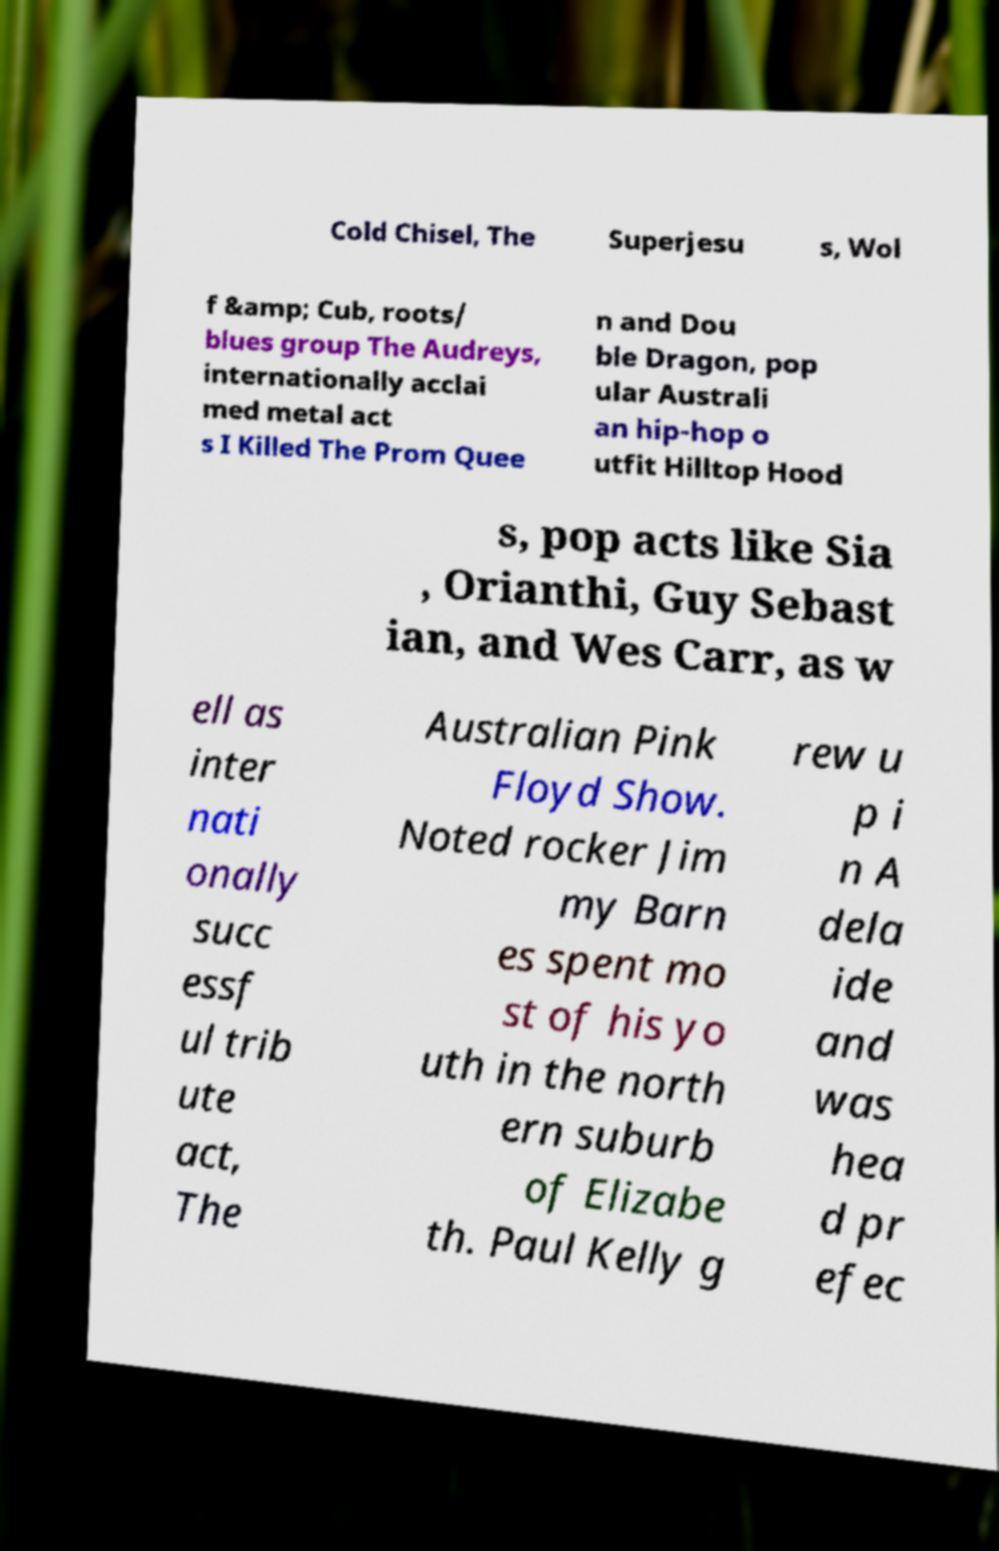Please identify and transcribe the text found in this image. Cold Chisel, The Superjesu s, Wol f &amp; Cub, roots/ blues group The Audreys, internationally acclai med metal act s I Killed The Prom Quee n and Dou ble Dragon, pop ular Australi an hip-hop o utfit Hilltop Hood s, pop acts like Sia , Orianthi, Guy Sebast ian, and Wes Carr, as w ell as inter nati onally succ essf ul trib ute act, The Australian Pink Floyd Show. Noted rocker Jim my Barn es spent mo st of his yo uth in the north ern suburb of Elizabe th. Paul Kelly g rew u p i n A dela ide and was hea d pr efec 